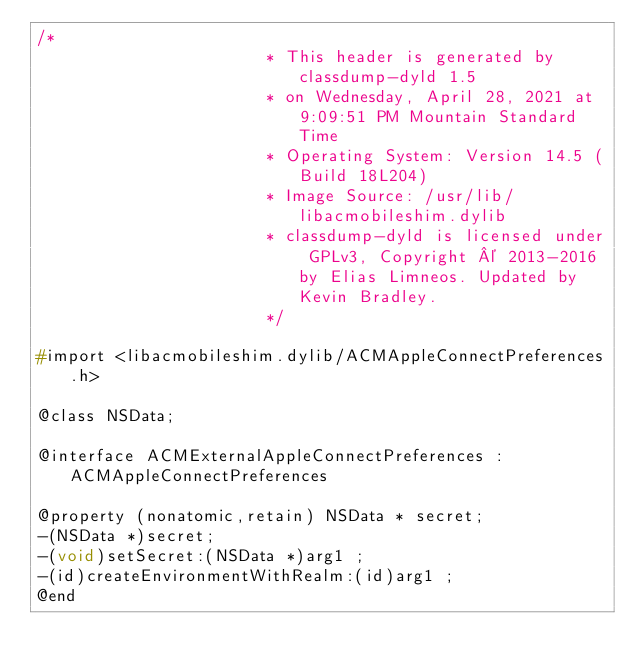<code> <loc_0><loc_0><loc_500><loc_500><_C_>/*
                       * This header is generated by classdump-dyld 1.5
                       * on Wednesday, April 28, 2021 at 9:09:51 PM Mountain Standard Time
                       * Operating System: Version 14.5 (Build 18L204)
                       * Image Source: /usr/lib/libacmobileshim.dylib
                       * classdump-dyld is licensed under GPLv3, Copyright © 2013-2016 by Elias Limneos. Updated by Kevin Bradley.
                       */

#import <libacmobileshim.dylib/ACMAppleConnectPreferences.h>

@class NSData;

@interface ACMExternalAppleConnectPreferences : ACMAppleConnectPreferences

@property (nonatomic,retain) NSData * secret; 
-(NSData *)secret;
-(void)setSecret:(NSData *)arg1 ;
-(id)createEnvironmentWithRealm:(id)arg1 ;
@end

</code> 